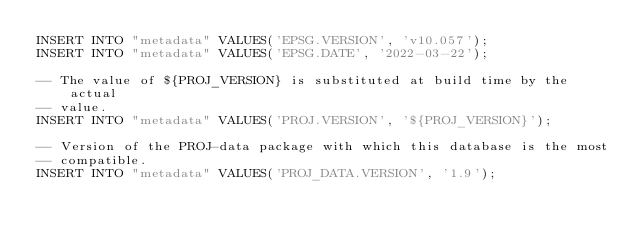<code> <loc_0><loc_0><loc_500><loc_500><_SQL_>INSERT INTO "metadata" VALUES('EPSG.VERSION', 'v10.057');
INSERT INTO "metadata" VALUES('EPSG.DATE', '2022-03-22');

-- The value of ${PROJ_VERSION} is substituted at build time by the actual
-- value.
INSERT INTO "metadata" VALUES('PROJ.VERSION', '${PROJ_VERSION}');

-- Version of the PROJ-data package with which this database is the most
-- compatible.
INSERT INTO "metadata" VALUES('PROJ_DATA.VERSION', '1.9');
</code> 